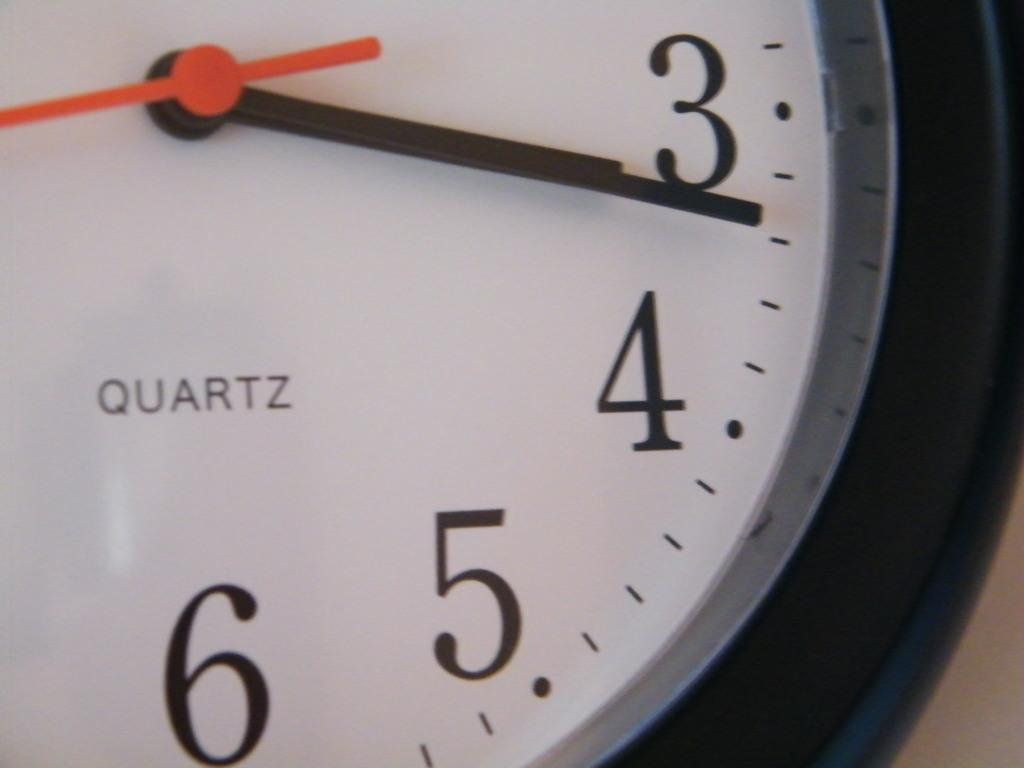Provide a one-sentence caption for the provided image. A clock with QUARTZ written on it shows the time as 3:17. 